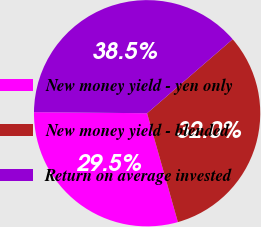Convert chart. <chart><loc_0><loc_0><loc_500><loc_500><pie_chart><fcel>New money yield - yen only<fcel>New money yield - blended<fcel>Return on average invested<nl><fcel>29.54%<fcel>31.96%<fcel>38.5%<nl></chart> 